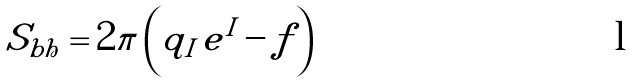<formula> <loc_0><loc_0><loc_500><loc_500>S _ { b h } = 2 \pi \left ( q _ { I } \, e ^ { I } - f \right )</formula> 